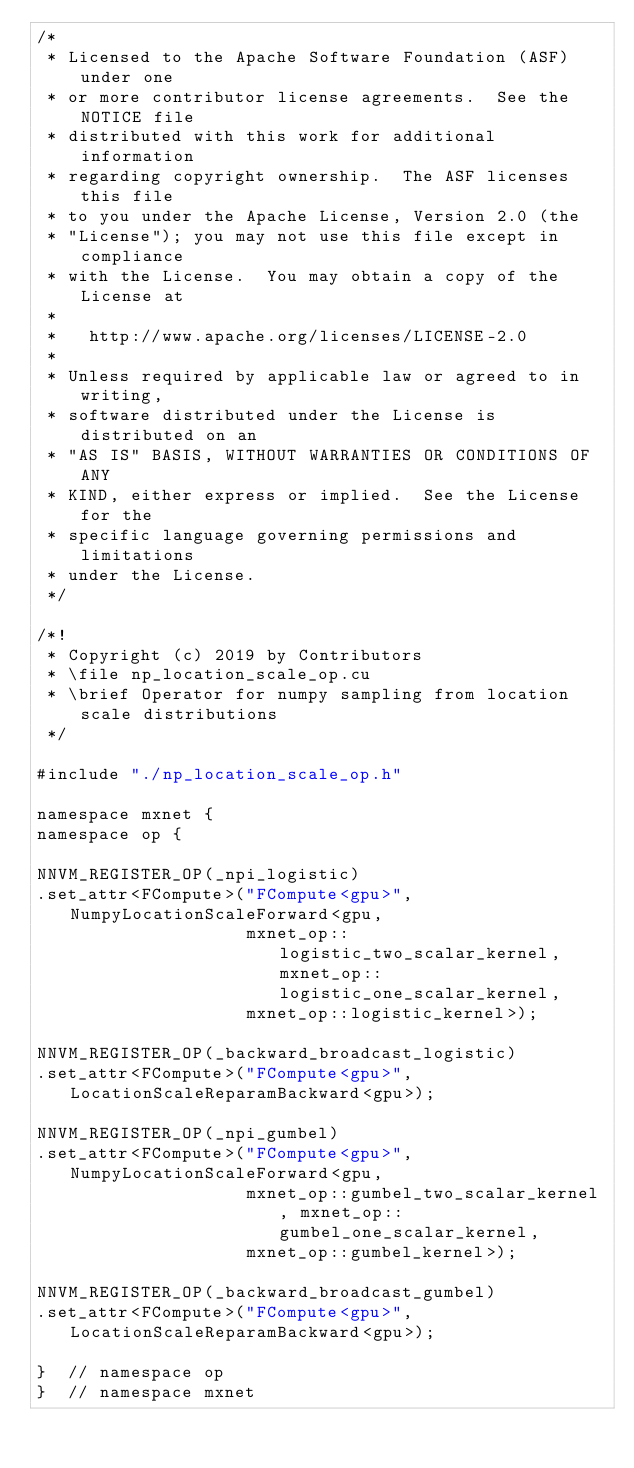Convert code to text. <code><loc_0><loc_0><loc_500><loc_500><_Cuda_>/*
 * Licensed to the Apache Software Foundation (ASF) under one
 * or more contributor license agreements.  See the NOTICE file
 * distributed with this work for additional information
 * regarding copyright ownership.  The ASF licenses this file
 * to you under the Apache License, Version 2.0 (the
 * "License"); you may not use this file except in compliance
 * with the License.  You may obtain a copy of the License at
 *
 *   http://www.apache.org/licenses/LICENSE-2.0
 *
 * Unless required by applicable law or agreed to in writing,
 * software distributed under the License is distributed on an
 * "AS IS" BASIS, WITHOUT WARRANTIES OR CONDITIONS OF ANY
 * KIND, either express or implied.  See the License for the
 * specific language governing permissions and limitations
 * under the License.
 */

/*!
 * Copyright (c) 2019 by Contributors
 * \file np_location_scale_op.cu
 * \brief Operator for numpy sampling from location scale distributions
 */

#include "./np_location_scale_op.h"

namespace mxnet {
namespace op {

NNVM_REGISTER_OP(_npi_logistic)
.set_attr<FCompute>("FCompute<gpu>", NumpyLocationScaleForward<gpu,
                    mxnet_op::logistic_two_scalar_kernel, mxnet_op::logistic_one_scalar_kernel,
                    mxnet_op::logistic_kernel>);

NNVM_REGISTER_OP(_backward_broadcast_logistic)
.set_attr<FCompute>("FCompute<gpu>", LocationScaleReparamBackward<gpu>);

NNVM_REGISTER_OP(_npi_gumbel)
.set_attr<FCompute>("FCompute<gpu>", NumpyLocationScaleForward<gpu,
                    mxnet_op::gumbel_two_scalar_kernel, mxnet_op::gumbel_one_scalar_kernel,
                    mxnet_op::gumbel_kernel>);

NNVM_REGISTER_OP(_backward_broadcast_gumbel)
.set_attr<FCompute>("FCompute<gpu>", LocationScaleReparamBackward<gpu>);

}  // namespace op
}  // namespace mxnet
</code> 